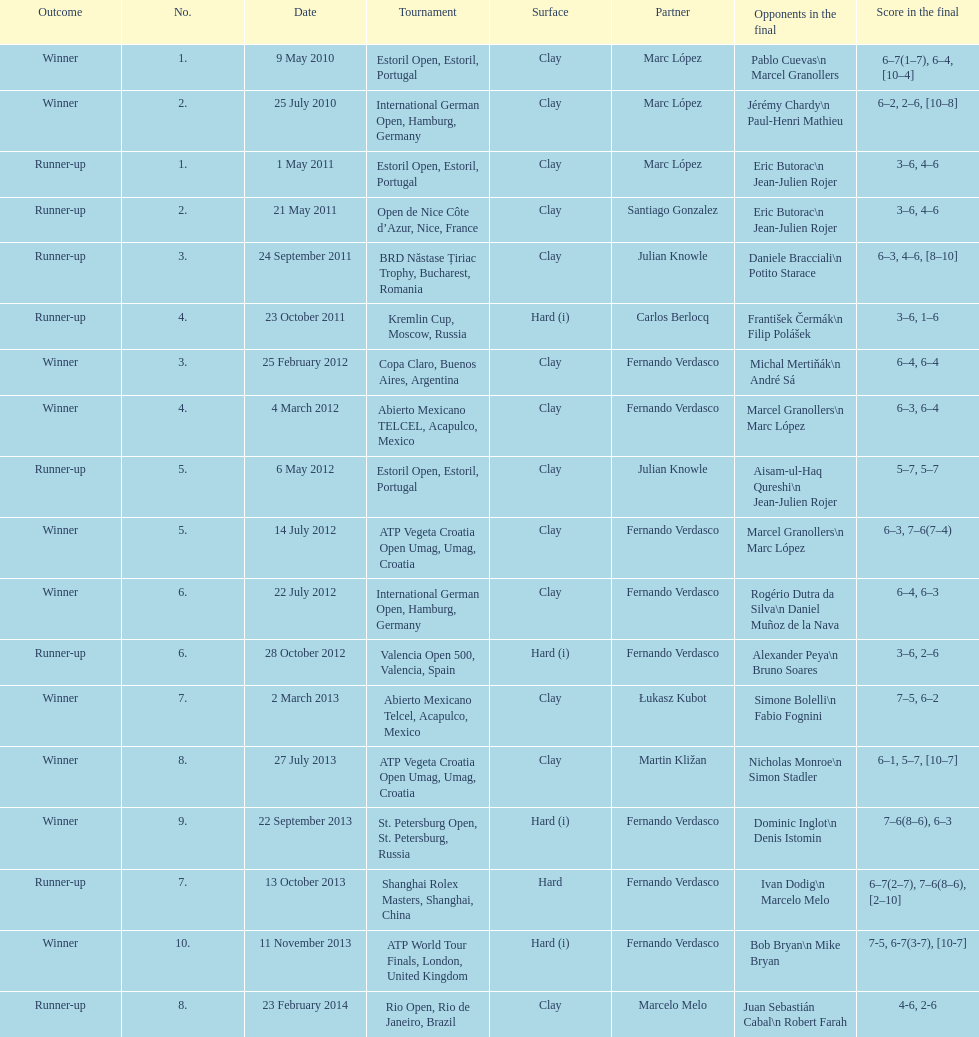What is the count of victorious outcomes? 10. 